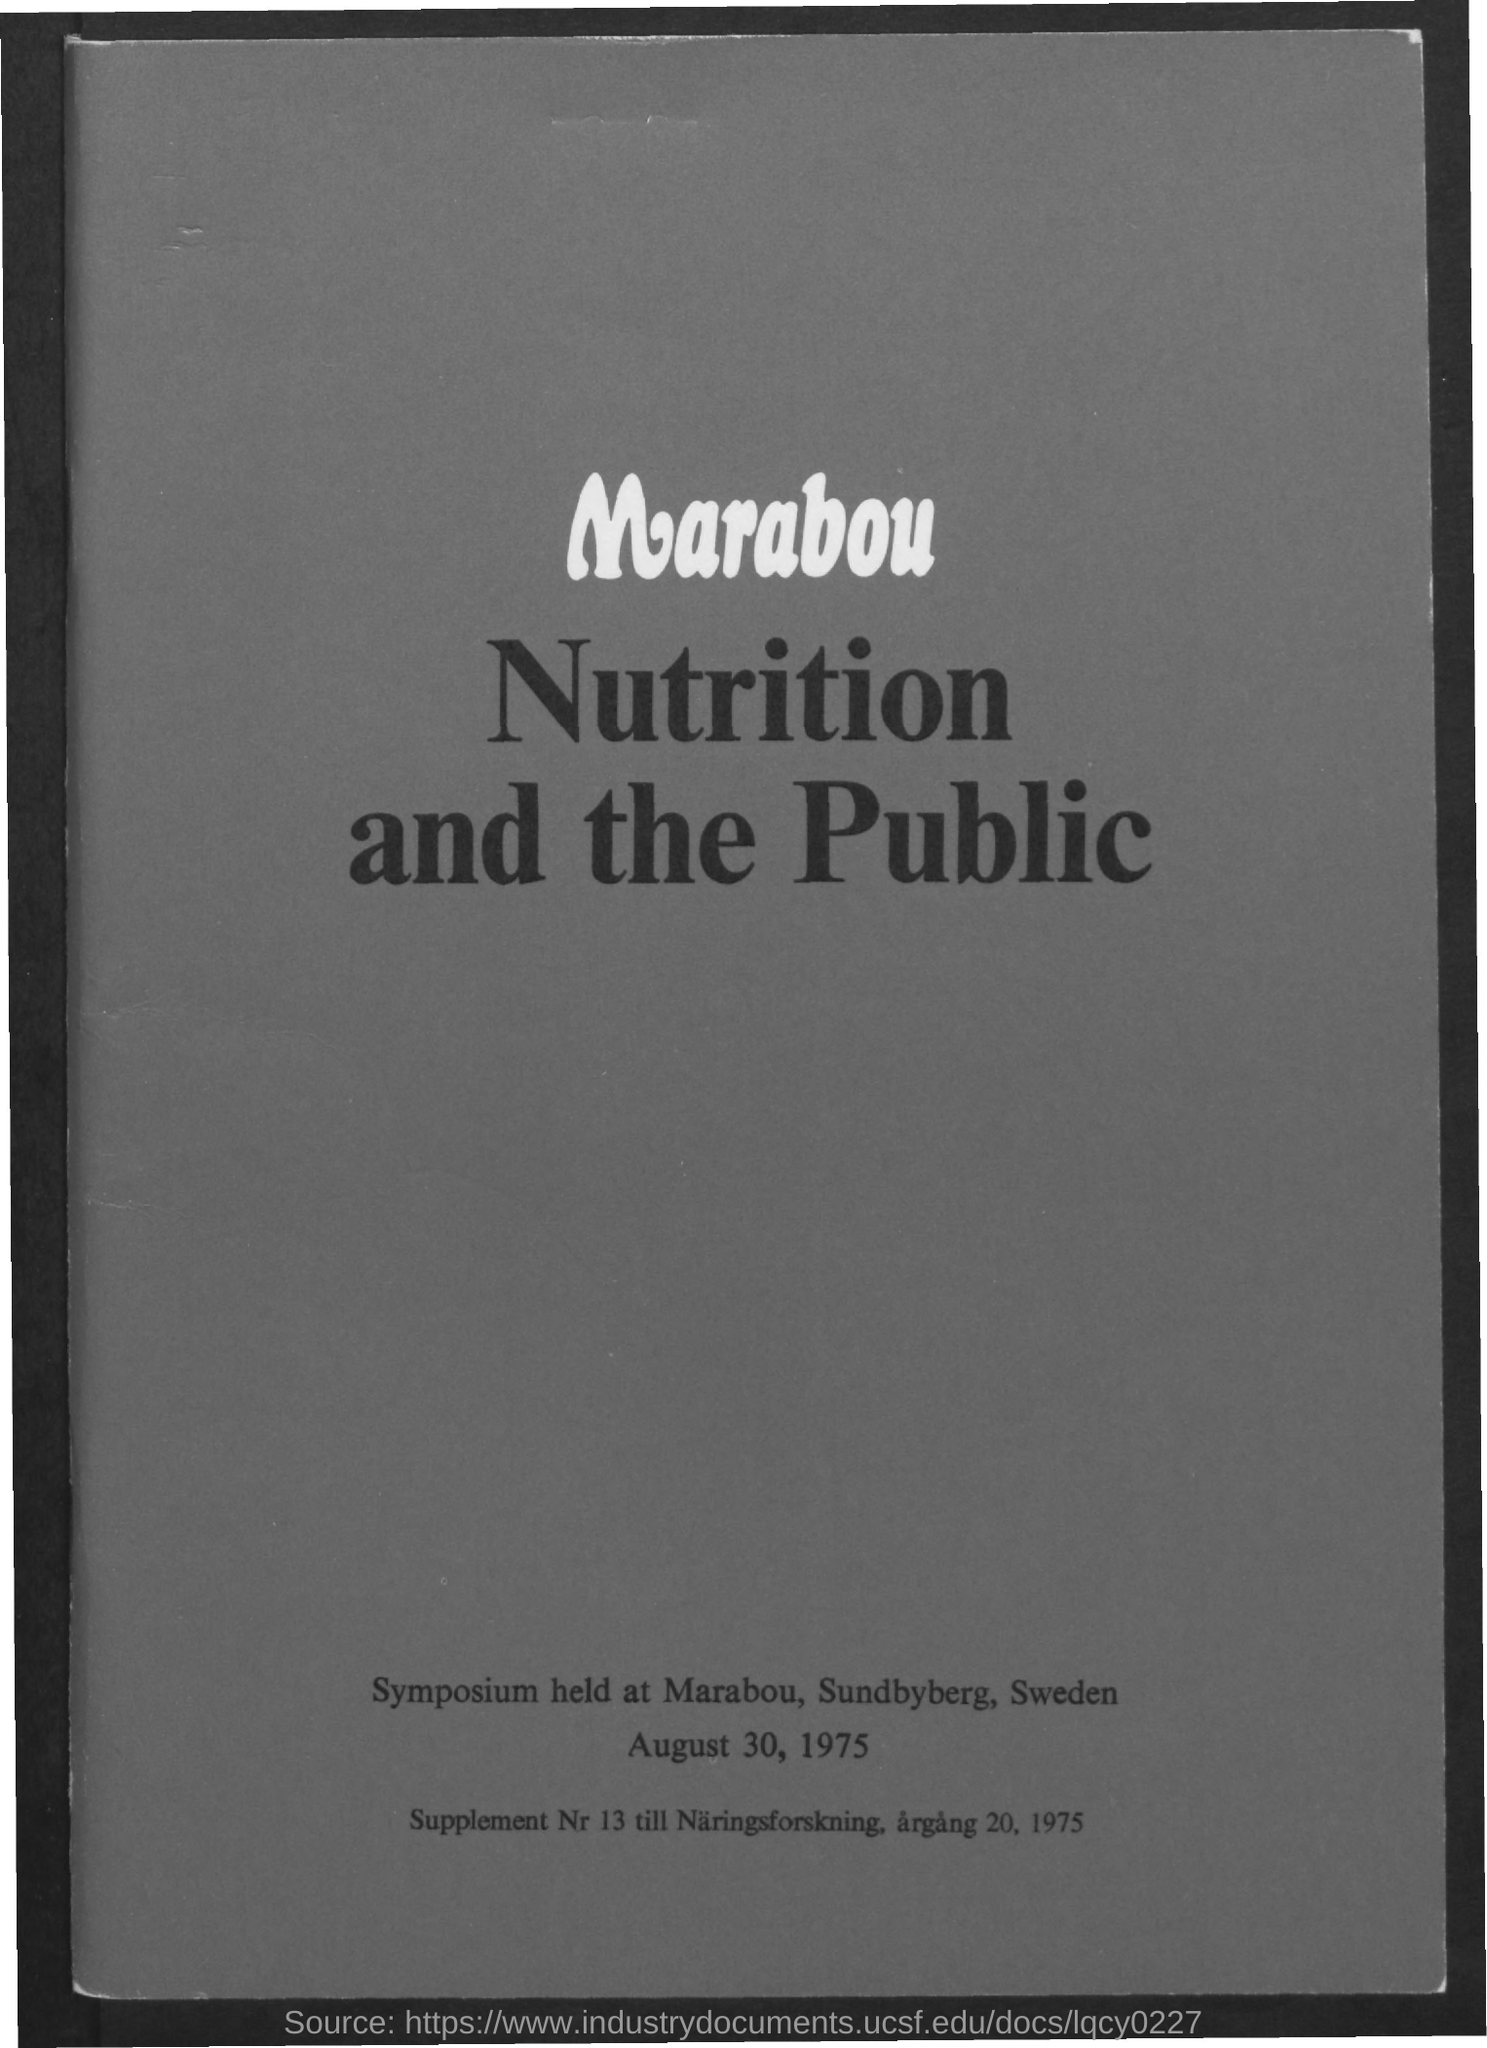Indicate a few pertinent items in this graphic. The symposium title is 'Nutrition and the Public'. The symposium was held at Marabou, Sundbyberg, Sweden. The symposium was held on August 30, 1975. 